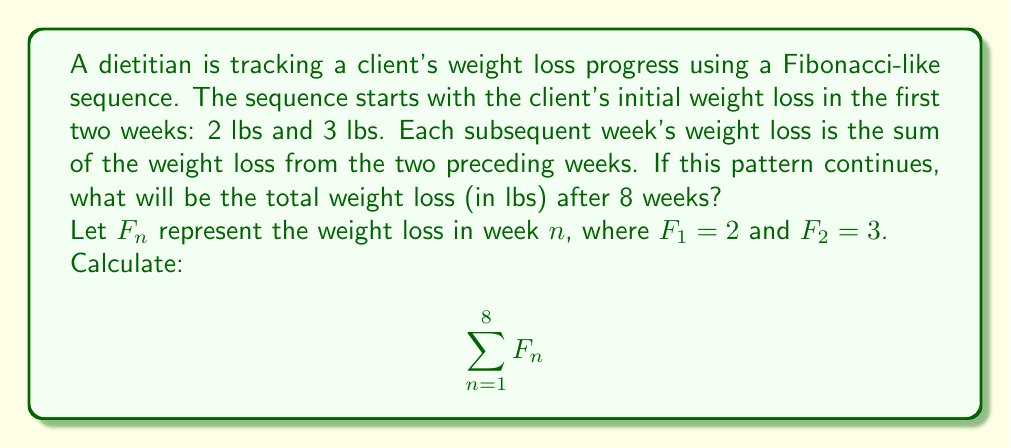Can you answer this question? To solve this problem, we need to generate the Fibonacci-like sequence for 8 weeks and then sum all the values. Let's break it down step-by-step:

1) We're given that $F_1 = 2$ and $F_2 = 3$.

2) For subsequent weeks, we use the Fibonacci rule: $F_n = F_{n-1} + F_{n-2}$

3) Let's calculate the sequence:
   $F_3 = F_2 + F_1 = 3 + 2 = 5$
   $F_4 = F_3 + F_2 = 5 + 3 = 8$
   $F_5 = F_4 + F_3 = 8 + 5 = 13$
   $F_6 = F_5 + F_4 = 13 + 8 = 21$
   $F_7 = F_6 + F_5 = 21 + 13 = 34$
   $F_8 = F_7 + F_6 = 34 + 21 = 55$

4) Now we have the complete sequence: 2, 3, 5, 8, 13, 21, 34, 55

5) To find the total weight loss, we sum all these values:

   $$\sum_{n=1}^8 F_n = 2 + 3 + 5 + 8 + 13 + 21 + 34 + 55 = 141$$

Therefore, the total weight loss after 8 weeks is 141 lbs.

Note: As a dietitian, it's important to point out that this rate of weight loss is unrealistic and potentially dangerous. A healthy rate of weight loss is typically 1-2 lbs per week.
Answer: 141 lbs 